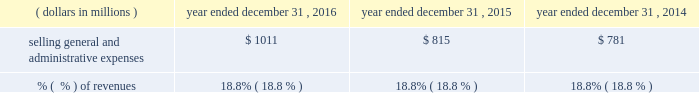2015 compared to 2014 when compared to 2014 , costs of revenue in 2015 increased $ 41 million .
This increase included a constant currency increase in expenses of approximately $ 238 million , or 8.9% ( 8.9 % ) , partially offset by a positive impact of approximately $ 197 million from the effects of foreign currency fluctuations .
The constant currency growth was comprised of a $ 71 million increase in commercial solutions , which included the impact from the encore acquisition which closed in july 2014 , a $ 146 million increase in research & development solutions , which included the incremental impact from the businesses that quest contributed to q2 solutions , and a $ 21 million increase in integrated engagement services .
The decrease in costs of revenue as a percent of revenues for 2015 was primarily as a result of an improvement in constant currency profit margin in the commercial solutions , research & development solutions and integrated engagement services segments ( as more fully described in the segment discussion later in this section ) .
For 2015 , this constant currency profit margin expansion was partially offset by the effect from a higher proportion of consolidated revenues being contributed by our lower margin integrated engagement services segment when compared to 2014 as well as a negative impact from foreign currency fluctuations .
Selling , general and administrative expenses , exclusive of depreciation and amortization .
2016 compared to 2015 the $ 196 million increase in selling , general and administrative expenses in 2016 included a constant currency increase of $ 215 million , or 26.4% ( 26.4 % ) , partially offset by a positive impact of approximately $ 19 million from the effects of foreign currency fluctuations .
The constant currency growth was comprised of a $ 151 million increase in commercial solutions , which includes $ 158 million from the merger with ims health , partially offset by a decline in the legacy service offerings , a $ 32 million increase in research & development solutions , which includes the incremental impact from the businesses that quest contributed to q2 solutions , a $ 3 million increase in integrated engagement services , and a $ 29 million increase in general corporate and unallocated expenses , which includes $ 37 million from the merger with ims health .
The constant currency increase in general corporate and unallocated expenses in 2016 was primarily due to higher stock-based compensation expense .
2015 compared to 2014 the $ 34 million increase in selling , general and administrative expenses in 2015 included a constant currency increase of $ 74 million , or 9.5% ( 9.5 % ) , partially offset by a positive impact of approximately $ 42 million from the effects of foreign currency fluctuations .
The constant currency growth was comprised of a $ 14 million increase in commercial solutions , which included the impact from the encore acquisition which closed in july 2014 , a $ 40 million increase in research & development solutions , which included the incremental impact from the businesses that quest contributed to q2 solutions , a $ 4 million increase in integrated engagement services , and a $ 14 million increase in general corporate and unallocated expenses .
The constant currency increase in general corporate and unallocated expenses in 2015 was primarily due to higher stock-based compensation expense and costs associated with the q2 solutions transaction. .
What was the percentage change in the selling , general and administrative expenses in 2015 from 2014? 
Computations: (34 / 781)
Answer: 0.04353. 